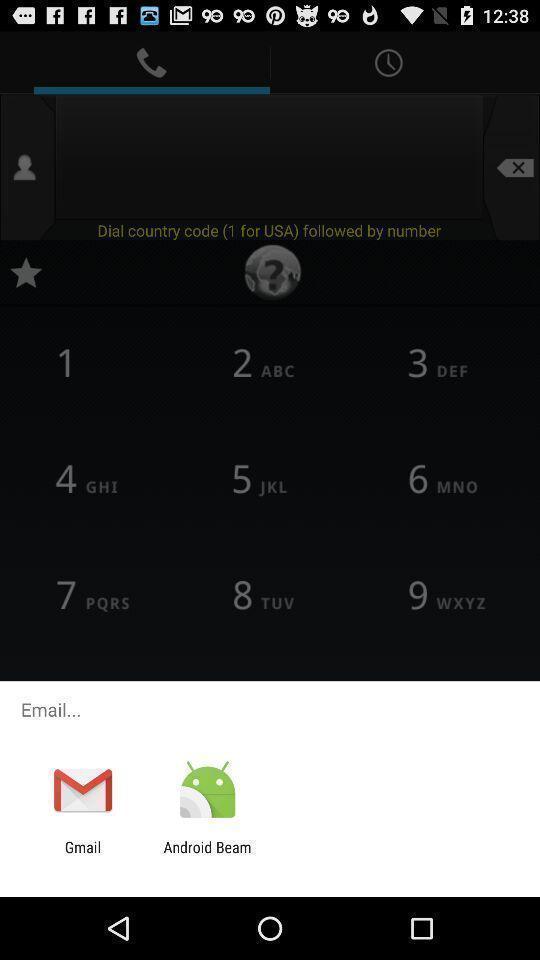What details can you identify in this image? Pop=up to email with multiple options. 